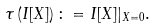Convert formula to latex. <formula><loc_0><loc_0><loc_500><loc_500>\tau \left ( I [ X ] \right ) \colon = I [ X ] | _ { X = 0 } .</formula> 